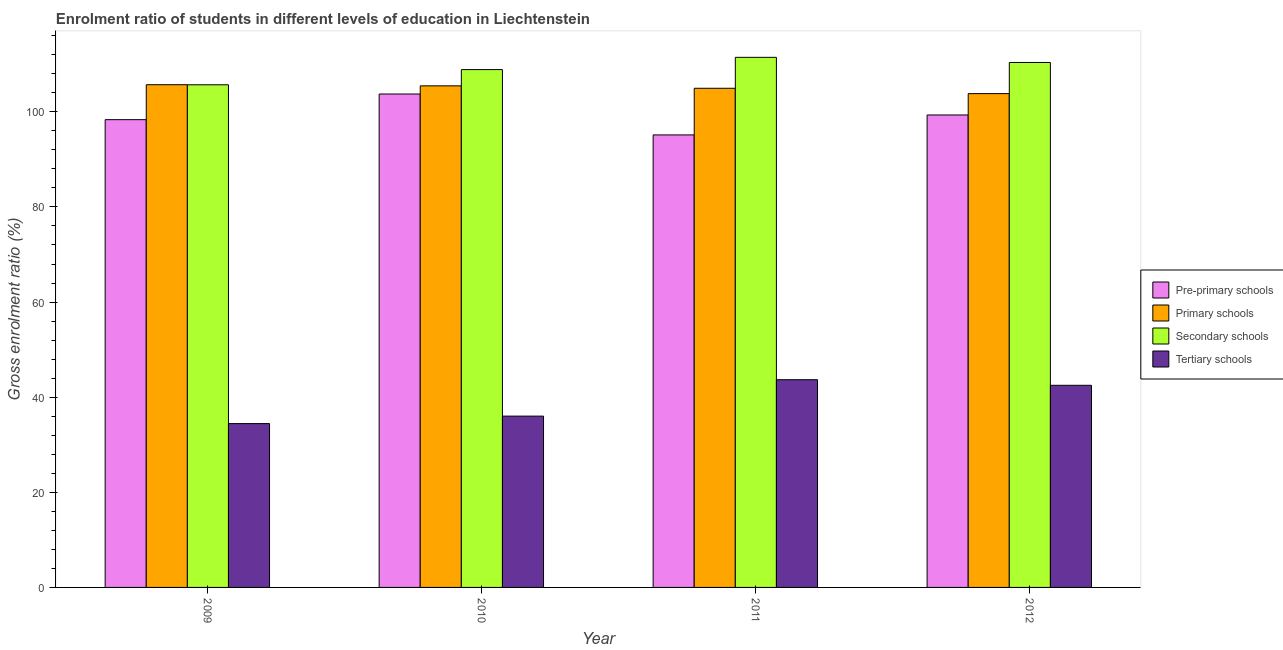How many different coloured bars are there?
Offer a very short reply. 4. How many groups of bars are there?
Offer a terse response. 4. Are the number of bars per tick equal to the number of legend labels?
Offer a very short reply. Yes. What is the label of the 2nd group of bars from the left?
Provide a succinct answer. 2010. In how many cases, is the number of bars for a given year not equal to the number of legend labels?
Offer a very short reply. 0. What is the gross enrolment ratio in primary schools in 2009?
Offer a terse response. 105.7. Across all years, what is the maximum gross enrolment ratio in tertiary schools?
Give a very brief answer. 43.68. Across all years, what is the minimum gross enrolment ratio in tertiary schools?
Give a very brief answer. 34.44. What is the total gross enrolment ratio in secondary schools in the graph?
Make the answer very short. 436.39. What is the difference between the gross enrolment ratio in pre-primary schools in 2010 and that in 2012?
Your answer should be compact. 4.41. What is the difference between the gross enrolment ratio in secondary schools in 2012 and the gross enrolment ratio in tertiary schools in 2010?
Provide a short and direct response. 1.49. What is the average gross enrolment ratio in tertiary schools per year?
Offer a very short reply. 39.16. In how many years, is the gross enrolment ratio in pre-primary schools greater than 32 %?
Make the answer very short. 4. What is the ratio of the gross enrolment ratio in secondary schools in 2009 to that in 2010?
Keep it short and to the point. 0.97. What is the difference between the highest and the second highest gross enrolment ratio in primary schools?
Provide a short and direct response. 0.24. What is the difference between the highest and the lowest gross enrolment ratio in tertiary schools?
Your answer should be very brief. 9.23. In how many years, is the gross enrolment ratio in tertiary schools greater than the average gross enrolment ratio in tertiary schools taken over all years?
Provide a succinct answer. 2. Is the sum of the gross enrolment ratio in primary schools in 2010 and 2012 greater than the maximum gross enrolment ratio in tertiary schools across all years?
Ensure brevity in your answer.  Yes. What does the 2nd bar from the left in 2010 represents?
Keep it short and to the point. Primary schools. What does the 4th bar from the right in 2011 represents?
Offer a terse response. Pre-primary schools. Is it the case that in every year, the sum of the gross enrolment ratio in pre-primary schools and gross enrolment ratio in primary schools is greater than the gross enrolment ratio in secondary schools?
Provide a succinct answer. Yes. What is the difference between two consecutive major ticks on the Y-axis?
Make the answer very short. 20. Does the graph contain grids?
Keep it short and to the point. No. What is the title of the graph?
Offer a terse response. Enrolment ratio of students in different levels of education in Liechtenstein. Does "Secondary vocational education" appear as one of the legend labels in the graph?
Your answer should be very brief. No. What is the label or title of the X-axis?
Ensure brevity in your answer.  Year. What is the label or title of the Y-axis?
Your answer should be compact. Gross enrolment ratio (%). What is the Gross enrolment ratio (%) in Pre-primary schools in 2009?
Your answer should be very brief. 98.35. What is the Gross enrolment ratio (%) of Primary schools in 2009?
Your answer should be compact. 105.7. What is the Gross enrolment ratio (%) in Secondary schools in 2009?
Provide a short and direct response. 105.68. What is the Gross enrolment ratio (%) in Tertiary schools in 2009?
Your answer should be compact. 34.44. What is the Gross enrolment ratio (%) in Pre-primary schools in 2010?
Provide a succinct answer. 103.74. What is the Gross enrolment ratio (%) in Primary schools in 2010?
Your answer should be very brief. 105.46. What is the Gross enrolment ratio (%) of Secondary schools in 2010?
Offer a terse response. 108.88. What is the Gross enrolment ratio (%) in Tertiary schools in 2010?
Make the answer very short. 36.02. What is the Gross enrolment ratio (%) of Pre-primary schools in 2011?
Provide a succinct answer. 95.14. What is the Gross enrolment ratio (%) in Primary schools in 2011?
Offer a terse response. 104.95. What is the Gross enrolment ratio (%) of Secondary schools in 2011?
Make the answer very short. 111.46. What is the Gross enrolment ratio (%) in Tertiary schools in 2011?
Make the answer very short. 43.68. What is the Gross enrolment ratio (%) in Pre-primary schools in 2012?
Ensure brevity in your answer.  99.34. What is the Gross enrolment ratio (%) of Primary schools in 2012?
Provide a short and direct response. 103.83. What is the Gross enrolment ratio (%) in Secondary schools in 2012?
Offer a very short reply. 110.37. What is the Gross enrolment ratio (%) of Tertiary schools in 2012?
Provide a short and direct response. 42.5. Across all years, what is the maximum Gross enrolment ratio (%) of Pre-primary schools?
Your response must be concise. 103.74. Across all years, what is the maximum Gross enrolment ratio (%) of Primary schools?
Make the answer very short. 105.7. Across all years, what is the maximum Gross enrolment ratio (%) in Secondary schools?
Offer a very short reply. 111.46. Across all years, what is the maximum Gross enrolment ratio (%) of Tertiary schools?
Your response must be concise. 43.68. Across all years, what is the minimum Gross enrolment ratio (%) of Pre-primary schools?
Make the answer very short. 95.14. Across all years, what is the minimum Gross enrolment ratio (%) of Primary schools?
Offer a very short reply. 103.83. Across all years, what is the minimum Gross enrolment ratio (%) of Secondary schools?
Provide a succinct answer. 105.68. Across all years, what is the minimum Gross enrolment ratio (%) of Tertiary schools?
Offer a terse response. 34.44. What is the total Gross enrolment ratio (%) of Pre-primary schools in the graph?
Give a very brief answer. 396.57. What is the total Gross enrolment ratio (%) in Primary schools in the graph?
Provide a succinct answer. 419.94. What is the total Gross enrolment ratio (%) of Secondary schools in the graph?
Your answer should be very brief. 436.39. What is the total Gross enrolment ratio (%) in Tertiary schools in the graph?
Keep it short and to the point. 156.63. What is the difference between the Gross enrolment ratio (%) in Pre-primary schools in 2009 and that in 2010?
Your answer should be compact. -5.4. What is the difference between the Gross enrolment ratio (%) of Primary schools in 2009 and that in 2010?
Give a very brief answer. 0.24. What is the difference between the Gross enrolment ratio (%) in Secondary schools in 2009 and that in 2010?
Provide a succinct answer. -3.19. What is the difference between the Gross enrolment ratio (%) of Tertiary schools in 2009 and that in 2010?
Offer a very short reply. -1.57. What is the difference between the Gross enrolment ratio (%) in Pre-primary schools in 2009 and that in 2011?
Offer a terse response. 3.21. What is the difference between the Gross enrolment ratio (%) in Primary schools in 2009 and that in 2011?
Your answer should be very brief. 0.75. What is the difference between the Gross enrolment ratio (%) in Secondary schools in 2009 and that in 2011?
Make the answer very short. -5.77. What is the difference between the Gross enrolment ratio (%) in Tertiary schools in 2009 and that in 2011?
Your answer should be very brief. -9.23. What is the difference between the Gross enrolment ratio (%) in Pre-primary schools in 2009 and that in 2012?
Your answer should be very brief. -0.99. What is the difference between the Gross enrolment ratio (%) in Primary schools in 2009 and that in 2012?
Offer a terse response. 1.87. What is the difference between the Gross enrolment ratio (%) in Secondary schools in 2009 and that in 2012?
Make the answer very short. -4.69. What is the difference between the Gross enrolment ratio (%) in Tertiary schools in 2009 and that in 2012?
Make the answer very short. -8.05. What is the difference between the Gross enrolment ratio (%) of Pre-primary schools in 2010 and that in 2011?
Your response must be concise. 8.6. What is the difference between the Gross enrolment ratio (%) of Primary schools in 2010 and that in 2011?
Ensure brevity in your answer.  0.51. What is the difference between the Gross enrolment ratio (%) of Secondary schools in 2010 and that in 2011?
Give a very brief answer. -2.58. What is the difference between the Gross enrolment ratio (%) of Tertiary schools in 2010 and that in 2011?
Keep it short and to the point. -7.66. What is the difference between the Gross enrolment ratio (%) in Pre-primary schools in 2010 and that in 2012?
Your response must be concise. 4.41. What is the difference between the Gross enrolment ratio (%) of Primary schools in 2010 and that in 2012?
Your response must be concise. 1.63. What is the difference between the Gross enrolment ratio (%) of Secondary schools in 2010 and that in 2012?
Provide a succinct answer. -1.49. What is the difference between the Gross enrolment ratio (%) in Tertiary schools in 2010 and that in 2012?
Ensure brevity in your answer.  -6.48. What is the difference between the Gross enrolment ratio (%) in Pre-primary schools in 2011 and that in 2012?
Keep it short and to the point. -4.19. What is the difference between the Gross enrolment ratio (%) of Primary schools in 2011 and that in 2012?
Provide a succinct answer. 1.12. What is the difference between the Gross enrolment ratio (%) of Secondary schools in 2011 and that in 2012?
Ensure brevity in your answer.  1.08. What is the difference between the Gross enrolment ratio (%) in Tertiary schools in 2011 and that in 2012?
Your answer should be very brief. 1.18. What is the difference between the Gross enrolment ratio (%) in Pre-primary schools in 2009 and the Gross enrolment ratio (%) in Primary schools in 2010?
Give a very brief answer. -7.11. What is the difference between the Gross enrolment ratio (%) in Pre-primary schools in 2009 and the Gross enrolment ratio (%) in Secondary schools in 2010?
Your answer should be very brief. -10.53. What is the difference between the Gross enrolment ratio (%) of Pre-primary schools in 2009 and the Gross enrolment ratio (%) of Tertiary schools in 2010?
Your answer should be compact. 62.33. What is the difference between the Gross enrolment ratio (%) in Primary schools in 2009 and the Gross enrolment ratio (%) in Secondary schools in 2010?
Offer a very short reply. -3.18. What is the difference between the Gross enrolment ratio (%) in Primary schools in 2009 and the Gross enrolment ratio (%) in Tertiary schools in 2010?
Make the answer very short. 69.68. What is the difference between the Gross enrolment ratio (%) of Secondary schools in 2009 and the Gross enrolment ratio (%) of Tertiary schools in 2010?
Offer a terse response. 69.67. What is the difference between the Gross enrolment ratio (%) in Pre-primary schools in 2009 and the Gross enrolment ratio (%) in Primary schools in 2011?
Make the answer very short. -6.6. What is the difference between the Gross enrolment ratio (%) of Pre-primary schools in 2009 and the Gross enrolment ratio (%) of Secondary schools in 2011?
Provide a succinct answer. -13.11. What is the difference between the Gross enrolment ratio (%) of Pre-primary schools in 2009 and the Gross enrolment ratio (%) of Tertiary schools in 2011?
Keep it short and to the point. 54.67. What is the difference between the Gross enrolment ratio (%) of Primary schools in 2009 and the Gross enrolment ratio (%) of Secondary schools in 2011?
Provide a short and direct response. -5.76. What is the difference between the Gross enrolment ratio (%) in Primary schools in 2009 and the Gross enrolment ratio (%) in Tertiary schools in 2011?
Give a very brief answer. 62.02. What is the difference between the Gross enrolment ratio (%) in Secondary schools in 2009 and the Gross enrolment ratio (%) in Tertiary schools in 2011?
Provide a short and direct response. 62.01. What is the difference between the Gross enrolment ratio (%) in Pre-primary schools in 2009 and the Gross enrolment ratio (%) in Primary schools in 2012?
Your answer should be compact. -5.48. What is the difference between the Gross enrolment ratio (%) of Pre-primary schools in 2009 and the Gross enrolment ratio (%) of Secondary schools in 2012?
Provide a succinct answer. -12.02. What is the difference between the Gross enrolment ratio (%) in Pre-primary schools in 2009 and the Gross enrolment ratio (%) in Tertiary schools in 2012?
Offer a terse response. 55.85. What is the difference between the Gross enrolment ratio (%) in Primary schools in 2009 and the Gross enrolment ratio (%) in Secondary schools in 2012?
Offer a very short reply. -4.68. What is the difference between the Gross enrolment ratio (%) in Primary schools in 2009 and the Gross enrolment ratio (%) in Tertiary schools in 2012?
Your response must be concise. 63.2. What is the difference between the Gross enrolment ratio (%) in Secondary schools in 2009 and the Gross enrolment ratio (%) in Tertiary schools in 2012?
Provide a short and direct response. 63.19. What is the difference between the Gross enrolment ratio (%) of Pre-primary schools in 2010 and the Gross enrolment ratio (%) of Primary schools in 2011?
Provide a short and direct response. -1.21. What is the difference between the Gross enrolment ratio (%) in Pre-primary schools in 2010 and the Gross enrolment ratio (%) in Secondary schools in 2011?
Give a very brief answer. -7.71. What is the difference between the Gross enrolment ratio (%) of Pre-primary schools in 2010 and the Gross enrolment ratio (%) of Tertiary schools in 2011?
Ensure brevity in your answer.  60.07. What is the difference between the Gross enrolment ratio (%) in Primary schools in 2010 and the Gross enrolment ratio (%) in Secondary schools in 2011?
Your answer should be very brief. -6. What is the difference between the Gross enrolment ratio (%) of Primary schools in 2010 and the Gross enrolment ratio (%) of Tertiary schools in 2011?
Provide a short and direct response. 61.78. What is the difference between the Gross enrolment ratio (%) in Secondary schools in 2010 and the Gross enrolment ratio (%) in Tertiary schools in 2011?
Make the answer very short. 65.2. What is the difference between the Gross enrolment ratio (%) of Pre-primary schools in 2010 and the Gross enrolment ratio (%) of Primary schools in 2012?
Provide a short and direct response. -0.08. What is the difference between the Gross enrolment ratio (%) in Pre-primary schools in 2010 and the Gross enrolment ratio (%) in Secondary schools in 2012?
Offer a terse response. -6.63. What is the difference between the Gross enrolment ratio (%) of Pre-primary schools in 2010 and the Gross enrolment ratio (%) of Tertiary schools in 2012?
Your answer should be very brief. 61.25. What is the difference between the Gross enrolment ratio (%) in Primary schools in 2010 and the Gross enrolment ratio (%) in Secondary schools in 2012?
Keep it short and to the point. -4.91. What is the difference between the Gross enrolment ratio (%) of Primary schools in 2010 and the Gross enrolment ratio (%) of Tertiary schools in 2012?
Your answer should be very brief. 62.96. What is the difference between the Gross enrolment ratio (%) in Secondary schools in 2010 and the Gross enrolment ratio (%) in Tertiary schools in 2012?
Offer a terse response. 66.38. What is the difference between the Gross enrolment ratio (%) in Pre-primary schools in 2011 and the Gross enrolment ratio (%) in Primary schools in 2012?
Provide a succinct answer. -8.68. What is the difference between the Gross enrolment ratio (%) of Pre-primary schools in 2011 and the Gross enrolment ratio (%) of Secondary schools in 2012?
Your answer should be compact. -15.23. What is the difference between the Gross enrolment ratio (%) in Pre-primary schools in 2011 and the Gross enrolment ratio (%) in Tertiary schools in 2012?
Ensure brevity in your answer.  52.65. What is the difference between the Gross enrolment ratio (%) in Primary schools in 2011 and the Gross enrolment ratio (%) in Secondary schools in 2012?
Provide a short and direct response. -5.42. What is the difference between the Gross enrolment ratio (%) in Primary schools in 2011 and the Gross enrolment ratio (%) in Tertiary schools in 2012?
Offer a very short reply. 62.45. What is the difference between the Gross enrolment ratio (%) of Secondary schools in 2011 and the Gross enrolment ratio (%) of Tertiary schools in 2012?
Offer a very short reply. 68.96. What is the average Gross enrolment ratio (%) of Pre-primary schools per year?
Your answer should be very brief. 99.14. What is the average Gross enrolment ratio (%) in Primary schools per year?
Your answer should be very brief. 104.98. What is the average Gross enrolment ratio (%) of Secondary schools per year?
Your response must be concise. 109.1. What is the average Gross enrolment ratio (%) in Tertiary schools per year?
Give a very brief answer. 39.16. In the year 2009, what is the difference between the Gross enrolment ratio (%) of Pre-primary schools and Gross enrolment ratio (%) of Primary schools?
Your answer should be very brief. -7.35. In the year 2009, what is the difference between the Gross enrolment ratio (%) in Pre-primary schools and Gross enrolment ratio (%) in Secondary schools?
Offer a terse response. -7.34. In the year 2009, what is the difference between the Gross enrolment ratio (%) in Pre-primary schools and Gross enrolment ratio (%) in Tertiary schools?
Ensure brevity in your answer.  63.9. In the year 2009, what is the difference between the Gross enrolment ratio (%) of Primary schools and Gross enrolment ratio (%) of Secondary schools?
Keep it short and to the point. 0.01. In the year 2009, what is the difference between the Gross enrolment ratio (%) of Primary schools and Gross enrolment ratio (%) of Tertiary schools?
Your response must be concise. 71.25. In the year 2009, what is the difference between the Gross enrolment ratio (%) of Secondary schools and Gross enrolment ratio (%) of Tertiary schools?
Make the answer very short. 71.24. In the year 2010, what is the difference between the Gross enrolment ratio (%) in Pre-primary schools and Gross enrolment ratio (%) in Primary schools?
Provide a short and direct response. -1.71. In the year 2010, what is the difference between the Gross enrolment ratio (%) in Pre-primary schools and Gross enrolment ratio (%) in Secondary schools?
Keep it short and to the point. -5.13. In the year 2010, what is the difference between the Gross enrolment ratio (%) of Pre-primary schools and Gross enrolment ratio (%) of Tertiary schools?
Your response must be concise. 67.73. In the year 2010, what is the difference between the Gross enrolment ratio (%) of Primary schools and Gross enrolment ratio (%) of Secondary schools?
Offer a very short reply. -3.42. In the year 2010, what is the difference between the Gross enrolment ratio (%) in Primary schools and Gross enrolment ratio (%) in Tertiary schools?
Give a very brief answer. 69.44. In the year 2010, what is the difference between the Gross enrolment ratio (%) of Secondary schools and Gross enrolment ratio (%) of Tertiary schools?
Give a very brief answer. 72.86. In the year 2011, what is the difference between the Gross enrolment ratio (%) of Pre-primary schools and Gross enrolment ratio (%) of Primary schools?
Your response must be concise. -9.81. In the year 2011, what is the difference between the Gross enrolment ratio (%) in Pre-primary schools and Gross enrolment ratio (%) in Secondary schools?
Offer a very short reply. -16.31. In the year 2011, what is the difference between the Gross enrolment ratio (%) in Pre-primary schools and Gross enrolment ratio (%) in Tertiary schools?
Offer a very short reply. 51.47. In the year 2011, what is the difference between the Gross enrolment ratio (%) in Primary schools and Gross enrolment ratio (%) in Secondary schools?
Offer a terse response. -6.51. In the year 2011, what is the difference between the Gross enrolment ratio (%) in Primary schools and Gross enrolment ratio (%) in Tertiary schools?
Ensure brevity in your answer.  61.28. In the year 2011, what is the difference between the Gross enrolment ratio (%) in Secondary schools and Gross enrolment ratio (%) in Tertiary schools?
Ensure brevity in your answer.  67.78. In the year 2012, what is the difference between the Gross enrolment ratio (%) of Pre-primary schools and Gross enrolment ratio (%) of Primary schools?
Make the answer very short. -4.49. In the year 2012, what is the difference between the Gross enrolment ratio (%) of Pre-primary schools and Gross enrolment ratio (%) of Secondary schools?
Provide a short and direct response. -11.04. In the year 2012, what is the difference between the Gross enrolment ratio (%) of Pre-primary schools and Gross enrolment ratio (%) of Tertiary schools?
Ensure brevity in your answer.  56.84. In the year 2012, what is the difference between the Gross enrolment ratio (%) in Primary schools and Gross enrolment ratio (%) in Secondary schools?
Your answer should be compact. -6.55. In the year 2012, what is the difference between the Gross enrolment ratio (%) of Primary schools and Gross enrolment ratio (%) of Tertiary schools?
Your answer should be very brief. 61.33. In the year 2012, what is the difference between the Gross enrolment ratio (%) in Secondary schools and Gross enrolment ratio (%) in Tertiary schools?
Ensure brevity in your answer.  67.88. What is the ratio of the Gross enrolment ratio (%) of Pre-primary schools in 2009 to that in 2010?
Ensure brevity in your answer.  0.95. What is the ratio of the Gross enrolment ratio (%) in Secondary schools in 2009 to that in 2010?
Offer a very short reply. 0.97. What is the ratio of the Gross enrolment ratio (%) of Tertiary schools in 2009 to that in 2010?
Your answer should be compact. 0.96. What is the ratio of the Gross enrolment ratio (%) in Pre-primary schools in 2009 to that in 2011?
Provide a succinct answer. 1.03. What is the ratio of the Gross enrolment ratio (%) in Primary schools in 2009 to that in 2011?
Your answer should be very brief. 1.01. What is the ratio of the Gross enrolment ratio (%) of Secondary schools in 2009 to that in 2011?
Your response must be concise. 0.95. What is the ratio of the Gross enrolment ratio (%) of Tertiary schools in 2009 to that in 2011?
Your response must be concise. 0.79. What is the ratio of the Gross enrolment ratio (%) of Primary schools in 2009 to that in 2012?
Your answer should be very brief. 1.02. What is the ratio of the Gross enrolment ratio (%) in Secondary schools in 2009 to that in 2012?
Offer a very short reply. 0.96. What is the ratio of the Gross enrolment ratio (%) in Tertiary schools in 2009 to that in 2012?
Your response must be concise. 0.81. What is the ratio of the Gross enrolment ratio (%) in Pre-primary schools in 2010 to that in 2011?
Ensure brevity in your answer.  1.09. What is the ratio of the Gross enrolment ratio (%) of Primary schools in 2010 to that in 2011?
Keep it short and to the point. 1. What is the ratio of the Gross enrolment ratio (%) of Secondary schools in 2010 to that in 2011?
Ensure brevity in your answer.  0.98. What is the ratio of the Gross enrolment ratio (%) in Tertiary schools in 2010 to that in 2011?
Provide a succinct answer. 0.82. What is the ratio of the Gross enrolment ratio (%) of Pre-primary schools in 2010 to that in 2012?
Offer a very short reply. 1.04. What is the ratio of the Gross enrolment ratio (%) of Primary schools in 2010 to that in 2012?
Your answer should be very brief. 1.02. What is the ratio of the Gross enrolment ratio (%) of Secondary schools in 2010 to that in 2012?
Provide a succinct answer. 0.99. What is the ratio of the Gross enrolment ratio (%) in Tertiary schools in 2010 to that in 2012?
Your response must be concise. 0.85. What is the ratio of the Gross enrolment ratio (%) of Pre-primary schools in 2011 to that in 2012?
Offer a very short reply. 0.96. What is the ratio of the Gross enrolment ratio (%) in Primary schools in 2011 to that in 2012?
Provide a short and direct response. 1.01. What is the ratio of the Gross enrolment ratio (%) of Secondary schools in 2011 to that in 2012?
Offer a very short reply. 1.01. What is the ratio of the Gross enrolment ratio (%) in Tertiary schools in 2011 to that in 2012?
Provide a short and direct response. 1.03. What is the difference between the highest and the second highest Gross enrolment ratio (%) of Pre-primary schools?
Provide a short and direct response. 4.41. What is the difference between the highest and the second highest Gross enrolment ratio (%) in Primary schools?
Ensure brevity in your answer.  0.24. What is the difference between the highest and the second highest Gross enrolment ratio (%) of Secondary schools?
Your answer should be very brief. 1.08. What is the difference between the highest and the second highest Gross enrolment ratio (%) of Tertiary schools?
Keep it short and to the point. 1.18. What is the difference between the highest and the lowest Gross enrolment ratio (%) of Pre-primary schools?
Your response must be concise. 8.6. What is the difference between the highest and the lowest Gross enrolment ratio (%) of Primary schools?
Your answer should be compact. 1.87. What is the difference between the highest and the lowest Gross enrolment ratio (%) of Secondary schools?
Offer a terse response. 5.77. What is the difference between the highest and the lowest Gross enrolment ratio (%) in Tertiary schools?
Give a very brief answer. 9.23. 